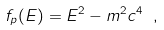Convert formula to latex. <formula><loc_0><loc_0><loc_500><loc_500>f _ { p } ( E ) = E ^ { 2 } - m ^ { 2 } c ^ { 4 } \ ,</formula> 